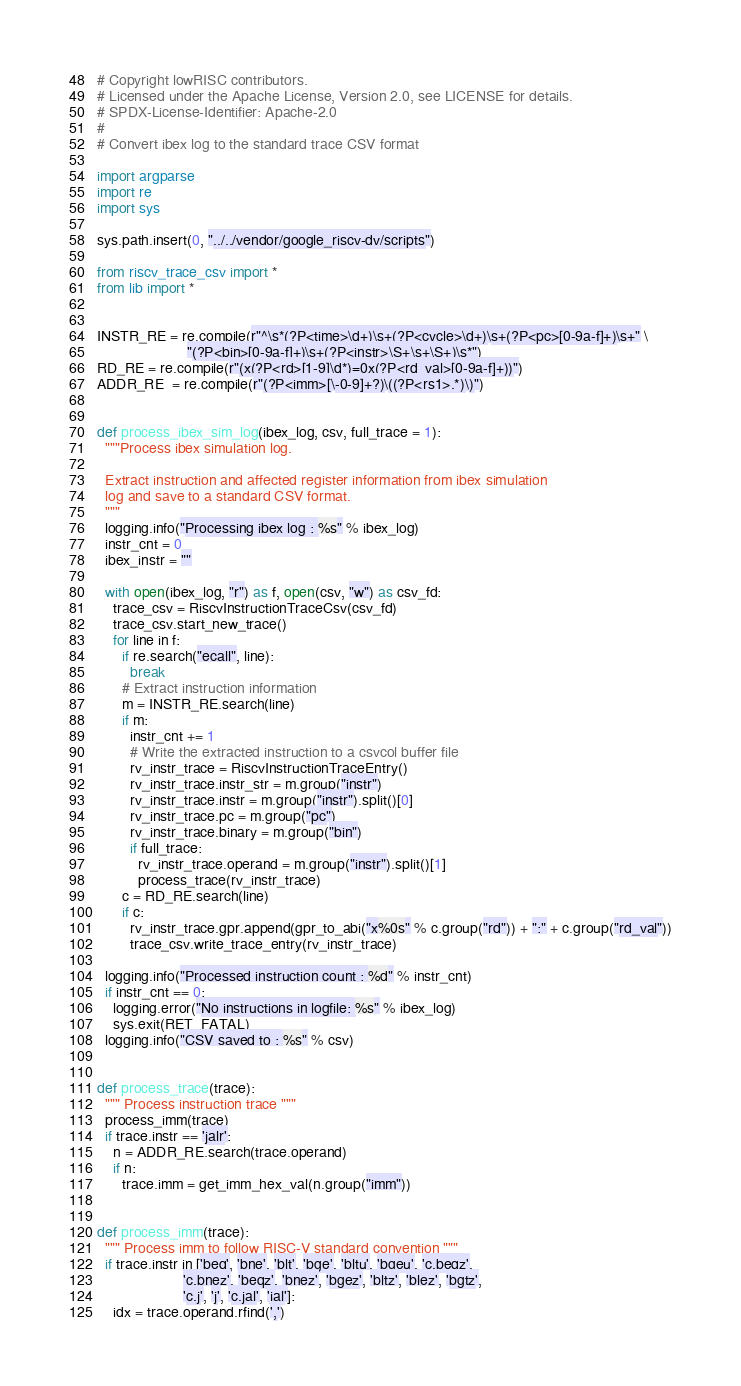Convert code to text. <code><loc_0><loc_0><loc_500><loc_500><_Python_># Copyright lowRISC contributors.
# Licensed under the Apache License, Version 2.0, see LICENSE for details.
# SPDX-License-Identifier: Apache-2.0
#
# Convert ibex log to the standard trace CSV format

import argparse
import re
import sys

sys.path.insert(0, "../../vendor/google_riscv-dv/scripts")

from riscv_trace_csv import *
from lib import *


INSTR_RE = re.compile(r"^\s*(?P<time>\d+)\s+(?P<cycle>\d+)\s+(?P<pc>[0-9a-f]+)\s+" \
                      "(?P<bin>[0-9a-f]+)\s+(?P<instr>\S+\s+\S+)\s*")
RD_RE = re.compile(r"(x(?P<rd>[1-9]\d*)=0x(?P<rd_val>[0-9a-f]+))")
ADDR_RE  = re.compile(r"(?P<imm>[\-0-9]+?)\((?P<rs1>.*)\)")


def process_ibex_sim_log(ibex_log, csv, full_trace = 1):
  """Process ibex simulation log.

  Extract instruction and affected register information from ibex simulation
  log and save to a standard CSV format.
  """
  logging.info("Processing ibex log : %s" % ibex_log)
  instr_cnt = 0
  ibex_instr = ""

  with open(ibex_log, "r") as f, open(csv, "w") as csv_fd:
    trace_csv = RiscvInstructionTraceCsv(csv_fd)
    trace_csv.start_new_trace()
    for line in f:
      if re.search("ecall", line):
        break
      # Extract instruction information
      m = INSTR_RE.search(line)
      if m:
        instr_cnt += 1
        # Write the extracted instruction to a csvcol buffer file
        rv_instr_trace = RiscvInstructionTraceEntry()
        rv_instr_trace.instr_str = m.group("instr")
        rv_instr_trace.instr = m.group("instr").split()[0]
        rv_instr_trace.pc = m.group("pc")
        rv_instr_trace.binary = m.group("bin")
        if full_trace:
          rv_instr_trace.operand = m.group("instr").split()[1]
          process_trace(rv_instr_trace)
      c = RD_RE.search(line)
      if c:
        rv_instr_trace.gpr.append(gpr_to_abi("x%0s" % c.group("rd")) + ":" + c.group("rd_val"))
        trace_csv.write_trace_entry(rv_instr_trace)

  logging.info("Processed instruction count : %d" % instr_cnt)
  if instr_cnt == 0:
    logging.error("No instructions in logfile: %s" % ibex_log)
    sys.exit(RET_FATAL)
  logging.info("CSV saved to : %s" % csv)


def process_trace(trace):
  """ Process instruction trace """
  process_imm(trace)
  if trace.instr == 'jalr':
    n = ADDR_RE.search(trace.operand)
    if n:
      trace.imm = get_imm_hex_val(n.group("imm"))


def process_imm(trace):
  """ Process imm to follow RISC-V standard convention """
  if trace.instr in ['beq', 'bne', 'blt', 'bge', 'bltu', 'bgeu', 'c.beqz',
                     'c.bnez', 'beqz', 'bnez', 'bgez', 'bltz', 'blez', 'bgtz',
                     'c.j', 'j', 'c.jal', 'jal']:
    idx = trace.operand.rfind(',')</code> 